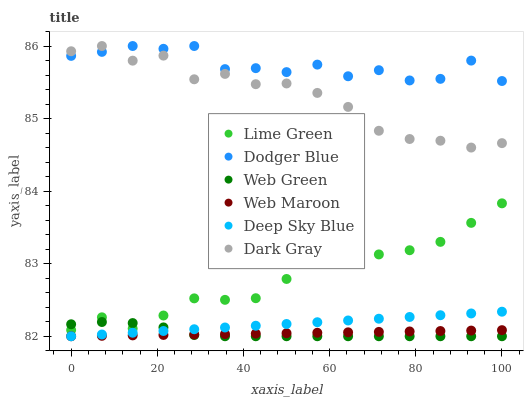Does Web Maroon have the minimum area under the curve?
Answer yes or no. Yes. Does Dodger Blue have the maximum area under the curve?
Answer yes or no. Yes. Does Web Green have the minimum area under the curve?
Answer yes or no. No. Does Web Green have the maximum area under the curve?
Answer yes or no. No. Is Deep Sky Blue the smoothest?
Answer yes or no. Yes. Is Dodger Blue the roughest?
Answer yes or no. Yes. Is Web Green the smoothest?
Answer yes or no. No. Is Web Green the roughest?
Answer yes or no. No. Does Web Maroon have the lowest value?
Answer yes or no. Yes. Does Dark Gray have the lowest value?
Answer yes or no. No. Does Dodger Blue have the highest value?
Answer yes or no. Yes. Does Web Green have the highest value?
Answer yes or no. No. Is Lime Green less than Dark Gray?
Answer yes or no. Yes. Is Lime Green greater than Deep Sky Blue?
Answer yes or no. Yes. Does Dodger Blue intersect Dark Gray?
Answer yes or no. Yes. Is Dodger Blue less than Dark Gray?
Answer yes or no. No. Is Dodger Blue greater than Dark Gray?
Answer yes or no. No. Does Lime Green intersect Dark Gray?
Answer yes or no. No. 